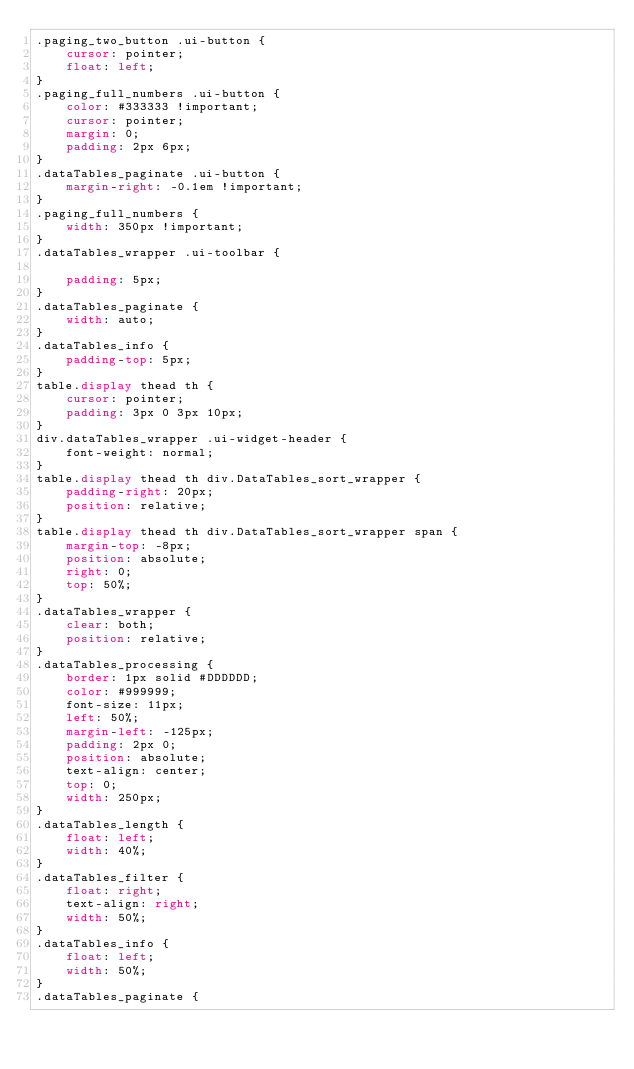<code> <loc_0><loc_0><loc_500><loc_500><_CSS_>.paging_two_button .ui-button {
    cursor: pointer;
    float: left;
}
.paging_full_numbers .ui-button {
    color: #333333 !important;
    cursor: pointer;
    margin: 0;
    padding: 2px 6px;
}
.dataTables_paginate .ui-button {
    margin-right: -0.1em !important;
}
.paging_full_numbers {
    width: 350px !important;
}
.dataTables_wrapper .ui-toolbar {
	
    padding: 5px;
}
.dataTables_paginate {
    width: auto;
}
.dataTables_info {
    padding-top: 5px;
}
table.display thead th {
    cursor: pointer;
    padding: 3px 0 3px 10px;
}
div.dataTables_wrapper .ui-widget-header {
    font-weight: normal;
}
table.display thead th div.DataTables_sort_wrapper {
    padding-right: 20px;
    position: relative;
}
table.display thead th div.DataTables_sort_wrapper span {
    margin-top: -8px;
    position: absolute;
    right: 0;
    top: 50%;
}
.dataTables_wrapper {
    clear: both;
    position: relative;
}
.dataTables_processing {
    border: 1px solid #DDDDDD;
    color: #999999;
    font-size: 11px;
    left: 50%;
    margin-left: -125px;
    padding: 2px 0;
    position: absolute;
    text-align: center;
    top: 0;
    width: 250px;
}
.dataTables_length {
    float: left;
    width: 40%;
}
.dataTables_filter {
    float: right;
    text-align: right;
    width: 50%;
}
.dataTables_info {
    float: left;
    width: 50%;
}
.dataTables_paginate {</code> 